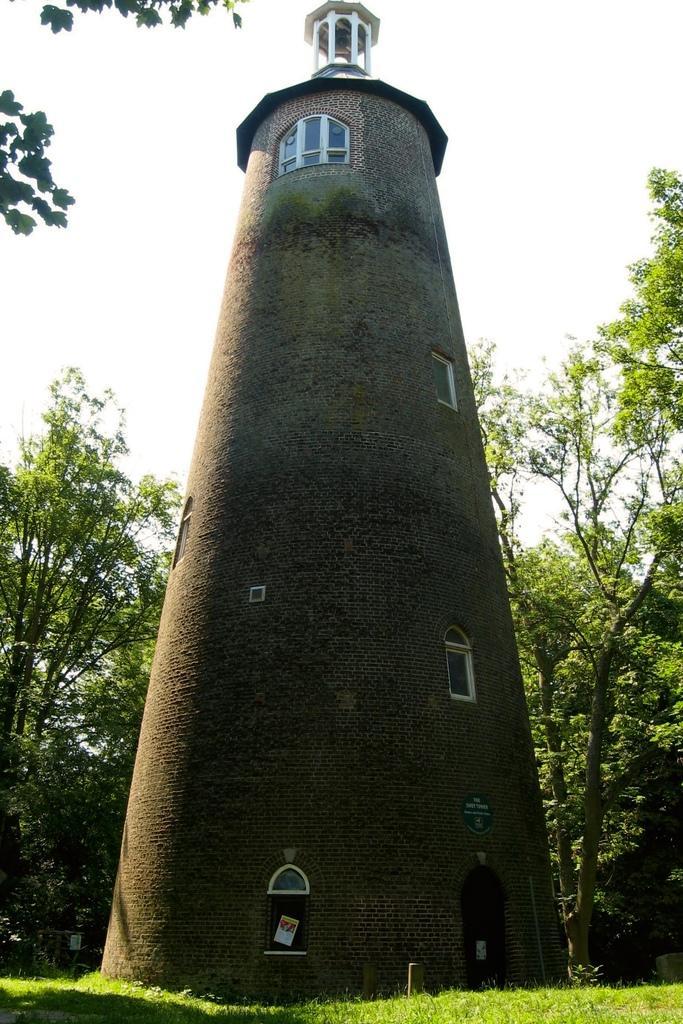Describe this image in one or two sentences. In this image there is a tall building. There is grass in the foreground. There are trees in the background. There is a sky. 